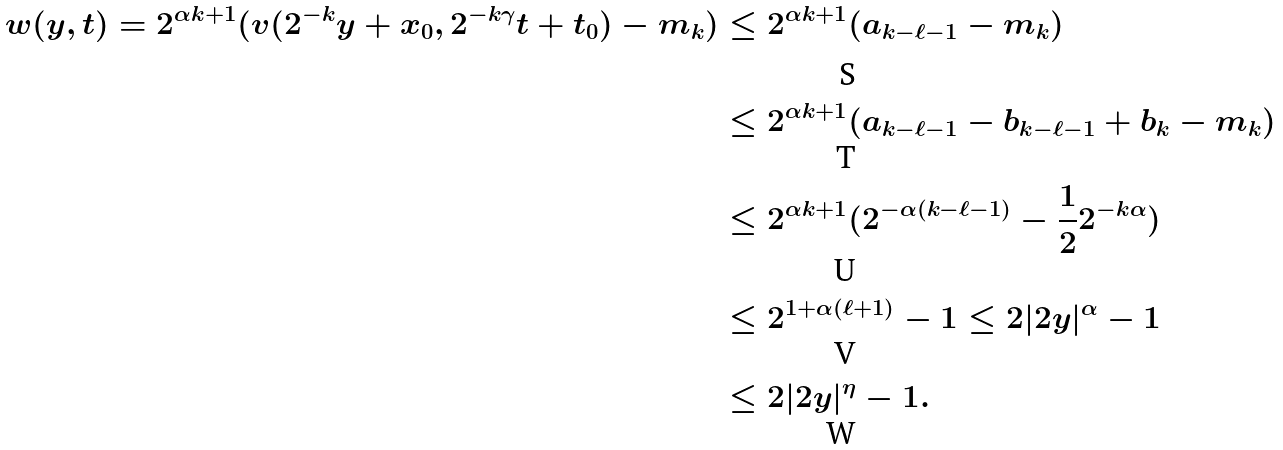<formula> <loc_0><loc_0><loc_500><loc_500>w ( y , t ) = 2 ^ { \alpha k + 1 } ( v ( 2 ^ { - k } y + x _ { 0 } , 2 ^ { - k \gamma } t + t _ { 0 } ) - m _ { k } ) & \leq 2 ^ { \alpha k + 1 } ( a _ { k - \ell - 1 } - m _ { k } ) \\ & \leq 2 ^ { \alpha k + 1 } ( a _ { k - \ell - 1 } - b _ { k - \ell - 1 } + b _ { k } - m _ { k } ) \\ & \leq 2 ^ { \alpha k + 1 } ( 2 ^ { - \alpha ( k - \ell - 1 ) } - \frac { 1 } { 2 } 2 ^ { - k \alpha } ) \\ & \leq 2 ^ { 1 + \alpha ( \ell + 1 ) } - 1 \leq 2 | 2 y | ^ { \alpha } - 1 \\ & \leq 2 | 2 y | ^ { \eta } - 1 .</formula> 